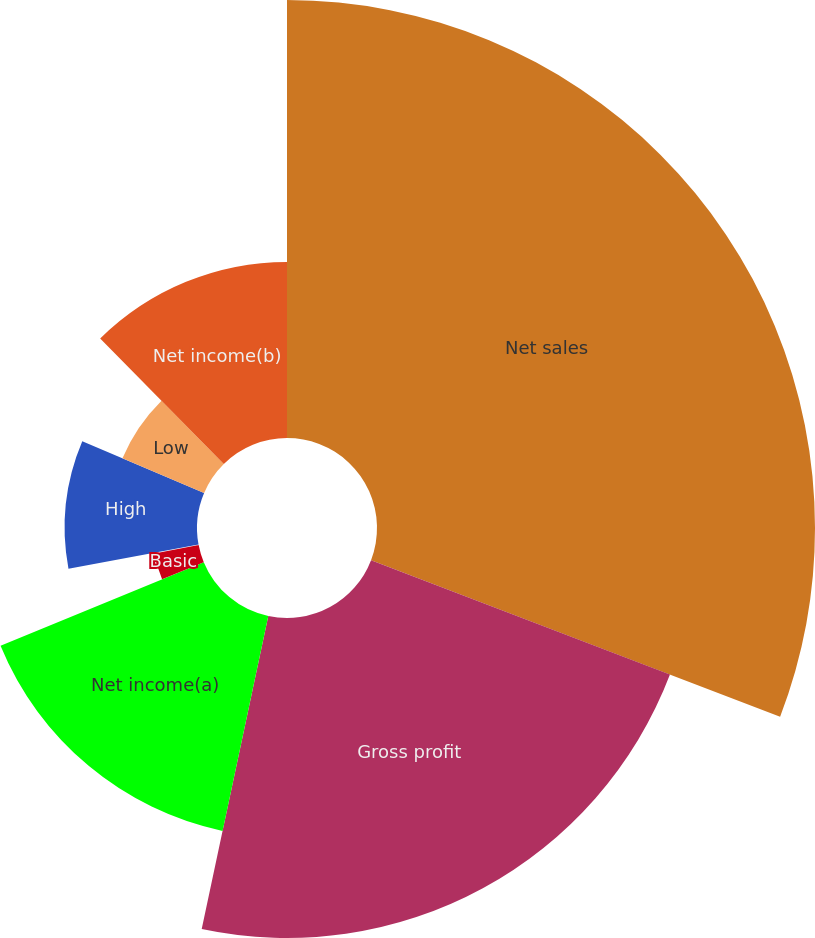<chart> <loc_0><loc_0><loc_500><loc_500><pie_chart><fcel>Net sales<fcel>Gross profit<fcel>Net income(a)<fcel>Basic<fcel>Diluted<fcel>High<fcel>Low<fcel>Net income(b)<nl><fcel>30.82%<fcel>22.52%<fcel>15.46%<fcel>3.17%<fcel>0.1%<fcel>9.31%<fcel>6.24%<fcel>12.39%<nl></chart> 